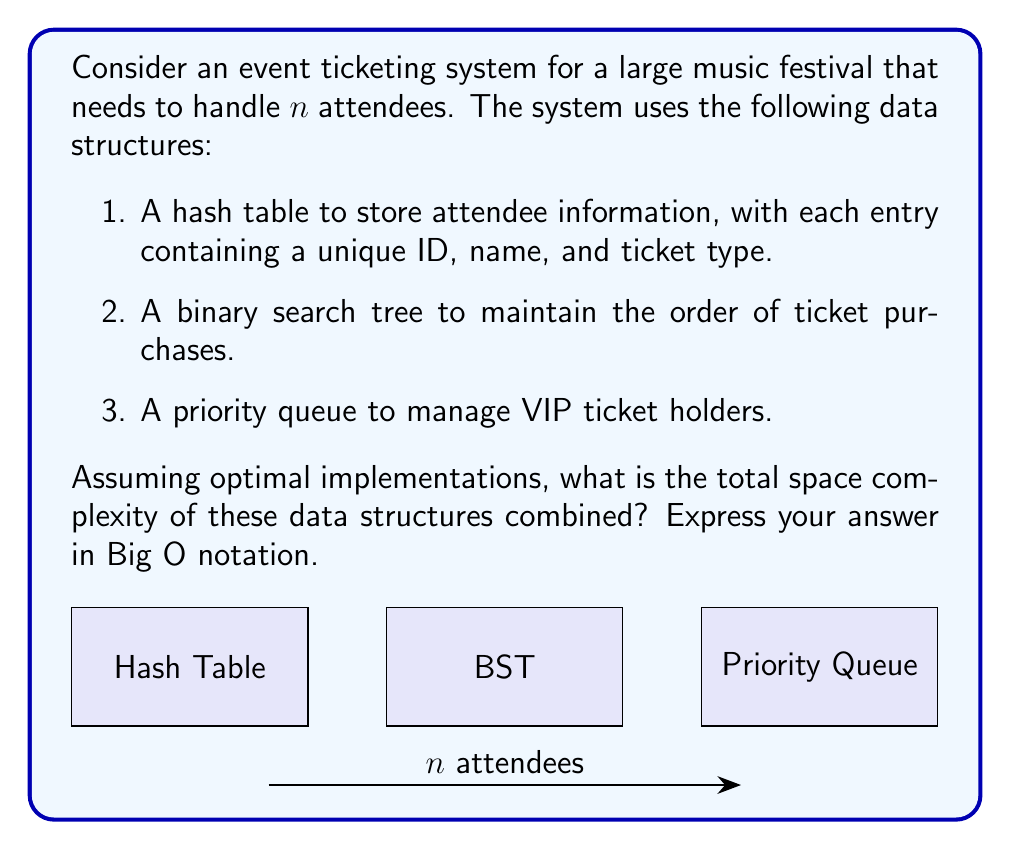Solve this math problem. Let's analyze the space complexity of each data structure:

1. Hash Table:
   - Each entry contains a unique ID, name, and ticket type.
   - Assuming constant space for each entry, the space required is $O(n)$.

2. Binary Search Tree (BST):
   - In a balanced BST, each node typically contains the data and two pointers.
   - The number of nodes is equal to the number of attendees.
   - The space complexity is $O(n)$.

3. Priority Queue:
   - Typically implemented as a binary heap.
   - The space required is proportional to the number of VIP ticket holders.
   - In the worst case (all attendees are VIP), this would be $O(n)$.

To calculate the total space complexity, we sum up the individual complexities:

$$O(n) + O(n) + O(n) = O(n)$$

The constant factors are absorbed in the Big O notation.

From a pragmatic perspective, while this space complexity is efficient, it's worth considering the real-world implications:
- The actual memory usage might be significant for very large festivals.
- There's a trade-off between space efficiency and the ability to quickly access and process attendee information.
- The system's design might impact the festival's ticket pricing and accessibility, potentially affecting the event's inclusivity.
Answer: $O(n)$ 